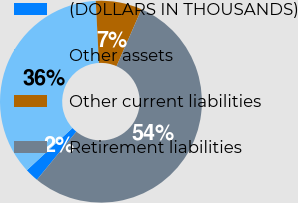Convert chart to OTSL. <chart><loc_0><loc_0><loc_500><loc_500><pie_chart><fcel>(DOLLARS IN THOUSANDS)<fcel>Other assets<fcel>Other current liabilities<fcel>Retirement liabilities<nl><fcel>2.19%<fcel>36.06%<fcel>7.41%<fcel>54.34%<nl></chart> 